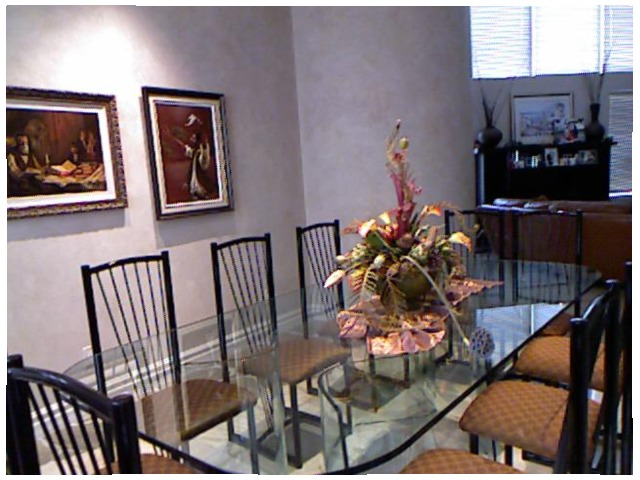<image>
Is there a flower vase on the glass table? Yes. Looking at the image, I can see the flower vase is positioned on top of the glass table, with the glass table providing support. Is there a flowers on the table? Yes. Looking at the image, I can see the flowers is positioned on top of the table, with the table providing support. Is the flower on the table? Yes. Looking at the image, I can see the flower is positioned on top of the table, with the table providing support. Where is the chair in relation to the table? Is it on the table? No. The chair is not positioned on the table. They may be near each other, but the chair is not supported by or resting on top of the table. Is there a table on the chair? No. The table is not positioned on the chair. They may be near each other, but the table is not supported by or resting on top of the chair. Is the chair to the right of the chair? Yes. From this viewpoint, the chair is positioned to the right side relative to the chair. Is the wall behind the chair? Yes. From this viewpoint, the wall is positioned behind the chair, with the chair partially or fully occluding the wall. 